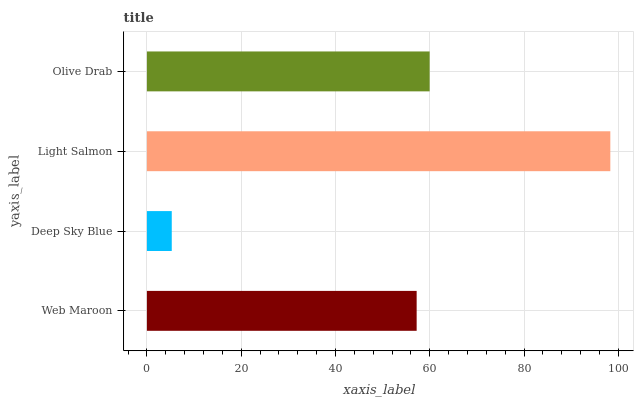Is Deep Sky Blue the minimum?
Answer yes or no. Yes. Is Light Salmon the maximum?
Answer yes or no. Yes. Is Light Salmon the minimum?
Answer yes or no. No. Is Deep Sky Blue the maximum?
Answer yes or no. No. Is Light Salmon greater than Deep Sky Blue?
Answer yes or no. Yes. Is Deep Sky Blue less than Light Salmon?
Answer yes or no. Yes. Is Deep Sky Blue greater than Light Salmon?
Answer yes or no. No. Is Light Salmon less than Deep Sky Blue?
Answer yes or no. No. Is Olive Drab the high median?
Answer yes or no. Yes. Is Web Maroon the low median?
Answer yes or no. Yes. Is Light Salmon the high median?
Answer yes or no. No. Is Deep Sky Blue the low median?
Answer yes or no. No. 